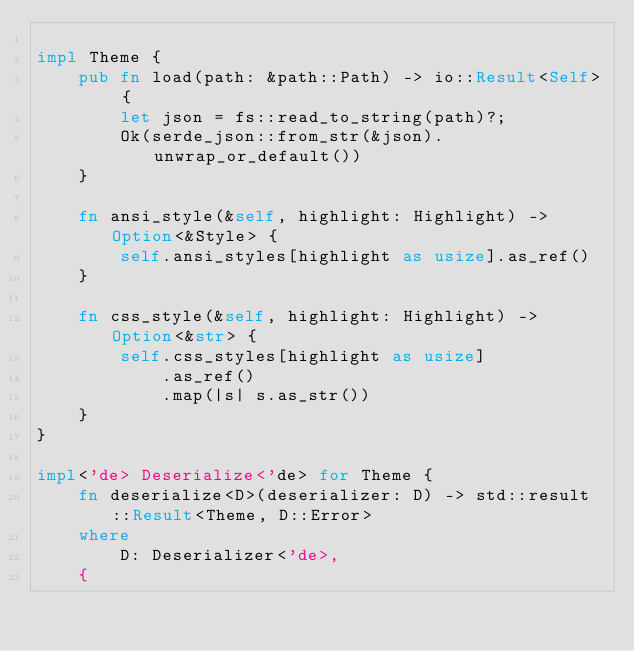<code> <loc_0><loc_0><loc_500><loc_500><_Rust_>
impl Theme {
    pub fn load(path: &path::Path) -> io::Result<Self> {
        let json = fs::read_to_string(path)?;
        Ok(serde_json::from_str(&json).unwrap_or_default())
    }

    fn ansi_style(&self, highlight: Highlight) -> Option<&Style> {
        self.ansi_styles[highlight as usize].as_ref()
    }

    fn css_style(&self, highlight: Highlight) -> Option<&str> {
        self.css_styles[highlight as usize]
            .as_ref()
            .map(|s| s.as_str())
    }
}

impl<'de> Deserialize<'de> for Theme {
    fn deserialize<D>(deserializer: D) -> std::result::Result<Theme, D::Error>
    where
        D: Deserializer<'de>,
    {</code> 